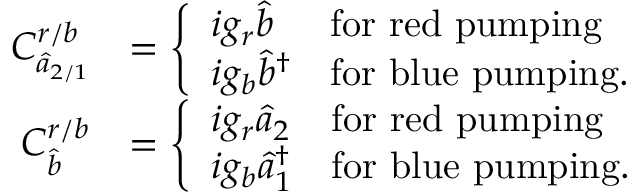Convert formula to latex. <formula><loc_0><loc_0><loc_500><loc_500>\begin{array} { r l } { C _ { \hat { a } _ { 2 / 1 } } ^ { r / b } } & { = \left \{ \begin{array} { l l } { i g _ { r } \hat { b } } & { f o r r e d p u m p i n g } \\ { i g _ { b } \hat { b } ^ { \dagger } } & { f o r b l u e p u m p i n g . } \end{array} } \\ { C _ { \hat { b } } ^ { r / b } } & { = \left \{ \begin{array} { l l } { i g _ { r } \hat { a } _ { 2 } } & { f o r r e d p u m p i n g } \\ { i g _ { b } \hat { a } _ { 1 } ^ { \dagger } } & { f o r b l u e p u m p i n g . } \end{array} } \end{array}</formula> 